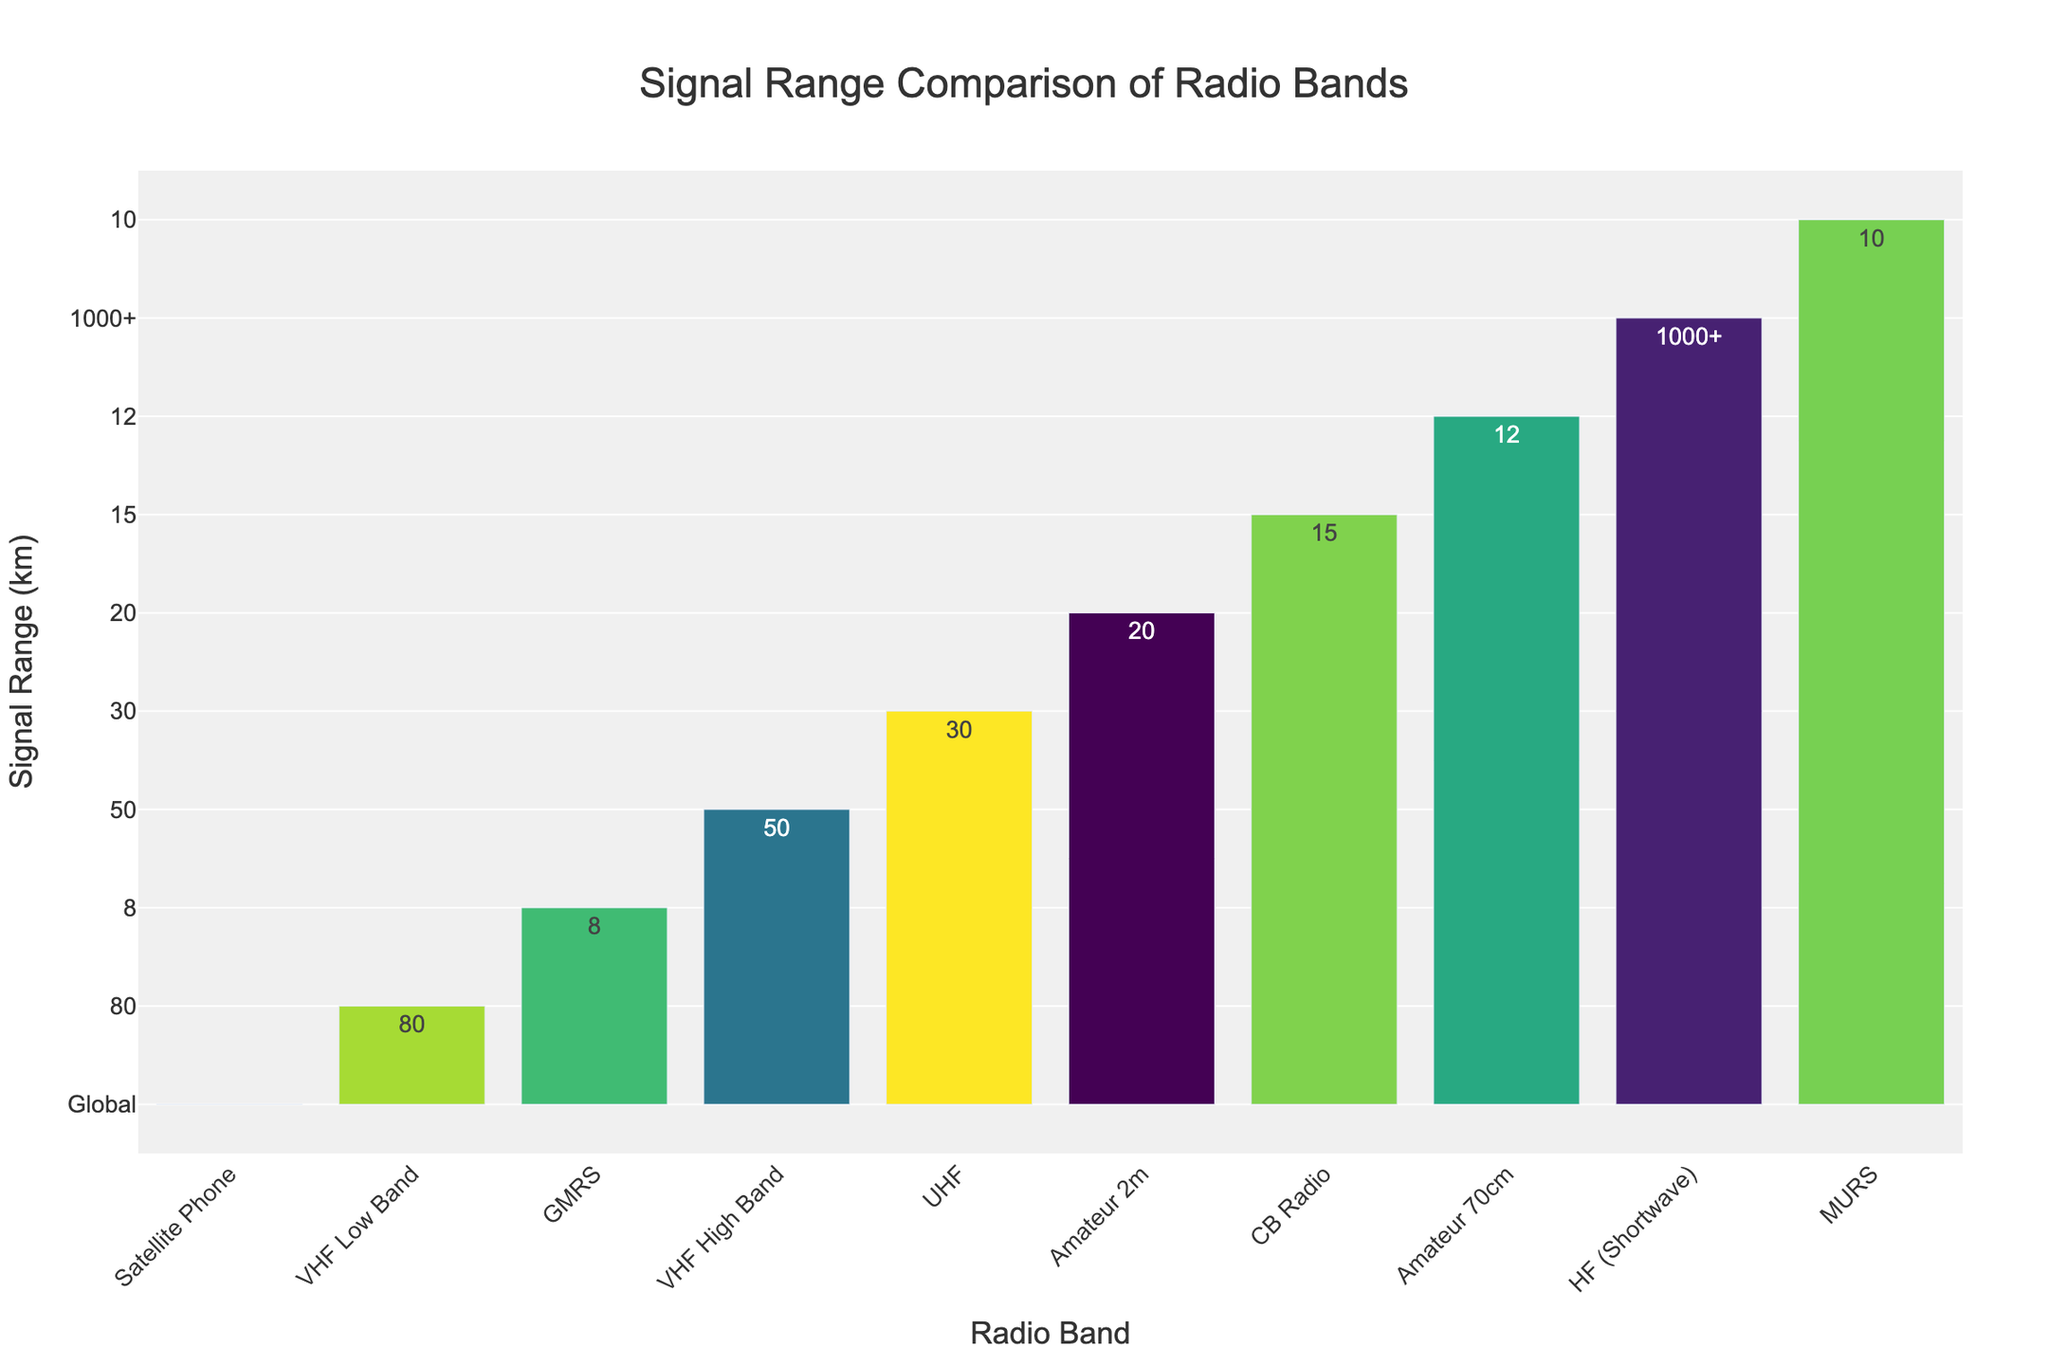Which radio band has the highest signal range? The bar chart shows that the HF (Shortwave) band has the highest bar, indicating it has the highest signal range of all the radio bands listed.
Answer: HF (Shortwave) What is the signal range of the VHF Low Band compared to the VHF High Band? Observing the bars for VHF Low Band and VHF High Band, VHF Low Band has a longer bar, indicating a signal range of 80 km, while VHF High Band has a shorter bar with a range of 50 km.
Answer: VHF Low Band is longer How do the signal ranges of Amateur 2m and Amateur 70cm bands compare? The chart shows that the Amateur 2m band has a longer bar than the Amateur 70cm band, indicating that the signal range for the Amateur 2m band (20 km) is greater than that of the Amateur 70cm band (12 km).
Answer: Amateur 2m is longer What is the cumulative signal range of all the UHF and VHF bands depicted? The VHF Low Band has a range of 80 km, the VHF High Band has a range of 50 km, and the UHF band has a range of 30 km. Summing these values: 80 + 50 + 30 = 160 km.
Answer: 160 km Which radio band has the shortest signal range? The bar chart shows that the GMRS band has the shortest bar, which indicates the shortest signal range of 8 km among all the radio bands listed.
Answer: GMRS Is the signal range of the Satellite Phone global? The bar corresponding to the Satellite Phone indicates 'Global' for the signal range, which confirms that its signal range is global.
Answer: Yes How many radio bands have a signal range of 50 km or more? By counting the bars whose signal ranges reach or exceed 50 km, we identify the HF (Shortwave), VHF Low Band, and VHF High Band. These three bands meet the criterion.
Answer: 3 bands What's the difference in signal range between the CB Radio and MURS bands? The signal range for CB Radio is 15 km, while for MURS, it is 10 km. The difference is 15 - 10 = 5 km.
Answer: 5 km What is the average signal range of the HF (Shortwave), VHF Low Band, and UHF bands? Add the signal ranges: HF (Shortwave) = 1000+ km, VHF Low Band = 80 km, UHF = 30 km. For simplicity, let's approximate the HF signal range as 1000 km. The sum is 1000 + 80 + 30 = 1110 km. The average is 1110 km / 3 = 370 km.
Answer: 370 km Which bands have a signal range less than that of the CB Radio? The bars for MURS (10 km), GMRS (8 km), and Amateur 70cm (12 km) are all shorter than that of the CB Radio (15 km), indicating they have a shorter signal range.
Answer: MURS, GMRS, Amateur 70cm How does the color of the bar for the HF (Shortwave) band compare to the color of the bar for the Amateur 2m band? According to the information provided, the bars are colored using the 'Viridis' colorscale, which varies in hue. Observing the chart, the color of the HF (Shortwave) bar appears distinctly different from the color of the Amateur 2m bar under this colorscale.
Answer: Different colors 